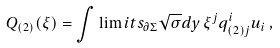Convert formula to latex. <formula><loc_0><loc_0><loc_500><loc_500>Q _ { ( 2 ) } ( \xi ) = \int \lim i t s _ { \partial \Sigma } \sqrt { \sigma } d y \, \xi ^ { j } q _ { ( 2 ) j } ^ { i } u _ { i } \, ,</formula> 